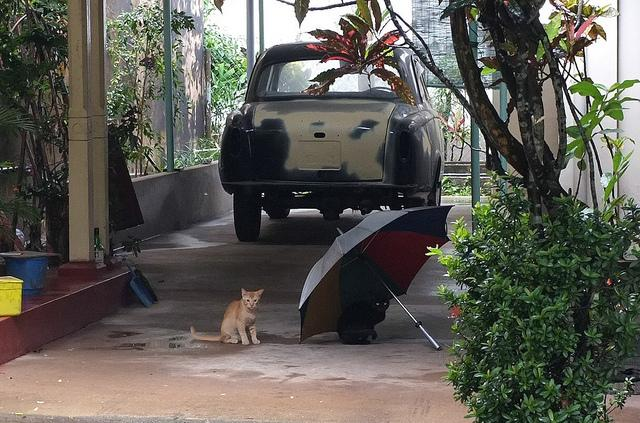What is under the umbrella? cat 